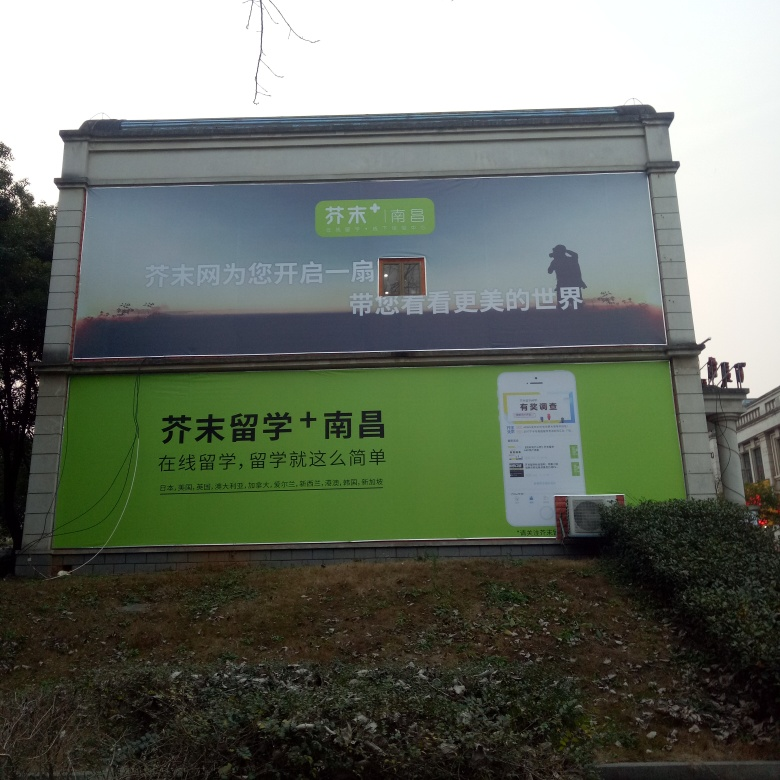Is the overall sharpness of the image good? While the image is mostly clear and the text is readable, there is slight blurriness, especially around the edges of the billboard and the smaller characters. The sharpness is adequate for comprehending the main elements of the image; however, a higher resolution would enhance the finer details. 